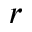<formula> <loc_0><loc_0><loc_500><loc_500>r</formula> 